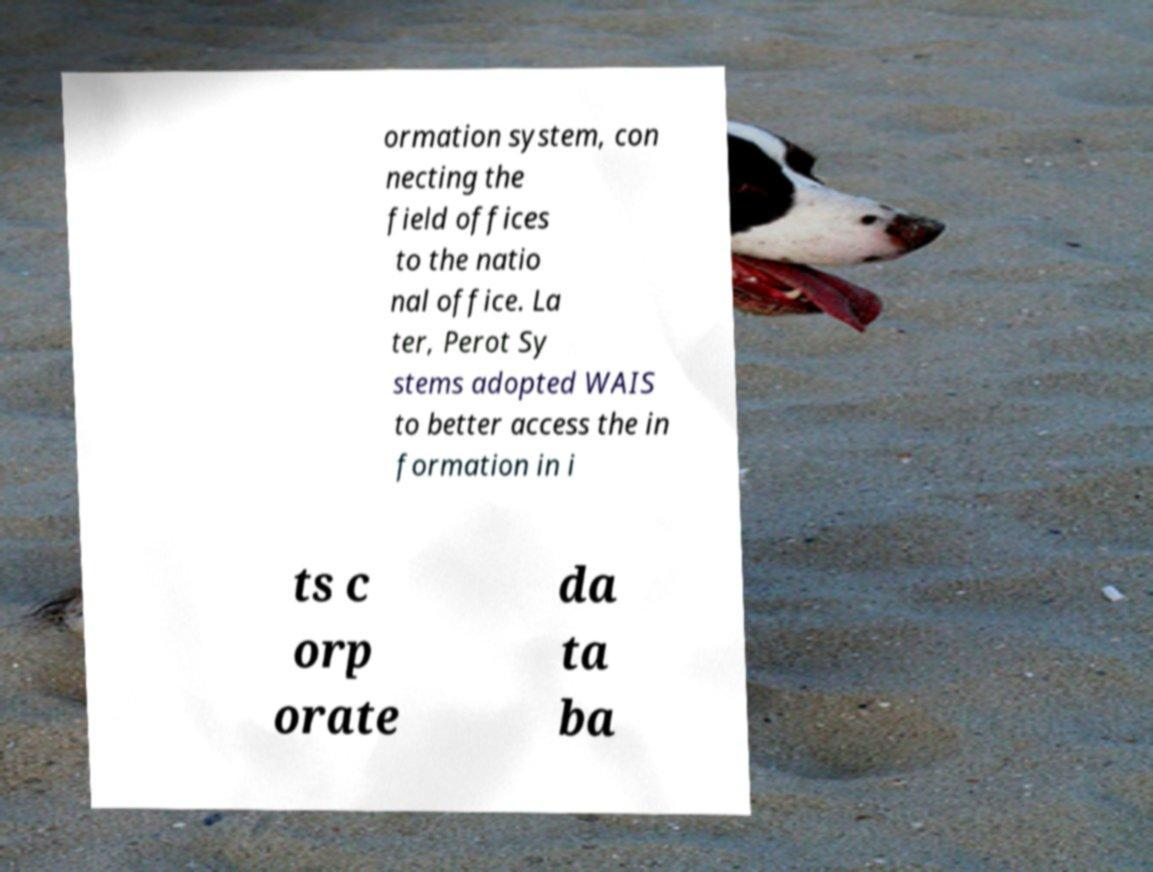Can you accurately transcribe the text from the provided image for me? ormation system, con necting the field offices to the natio nal office. La ter, Perot Sy stems adopted WAIS to better access the in formation in i ts c orp orate da ta ba 